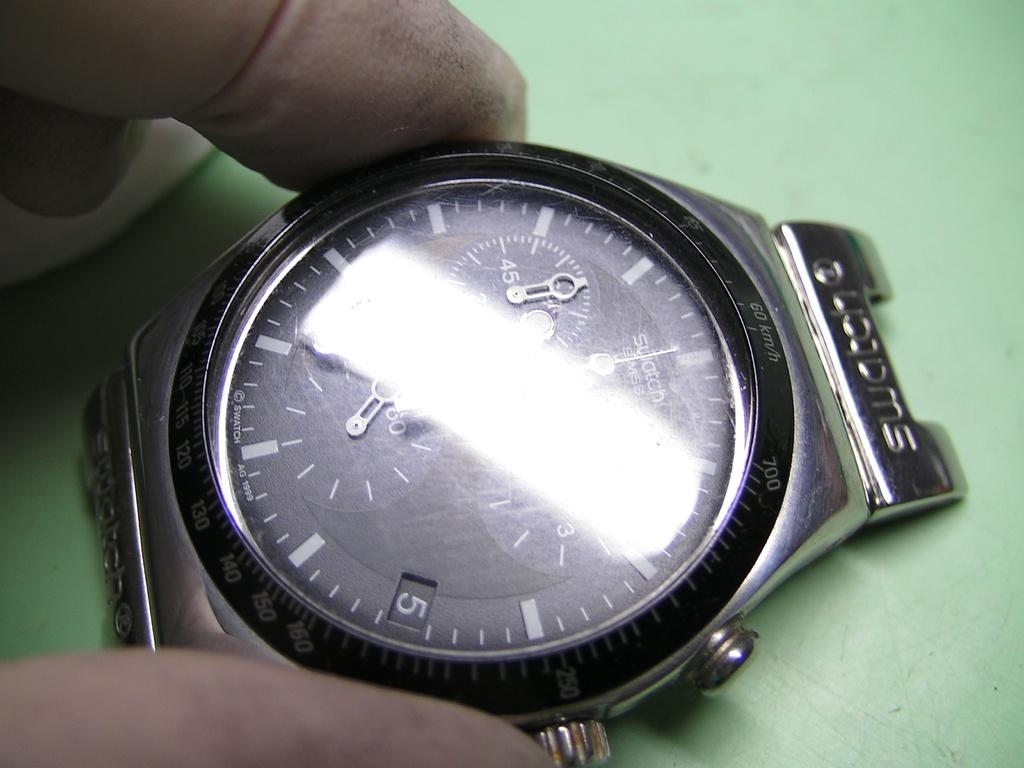Provide a one-sentence caption for the provided image. The brand of watch shown here is from Swatch. 